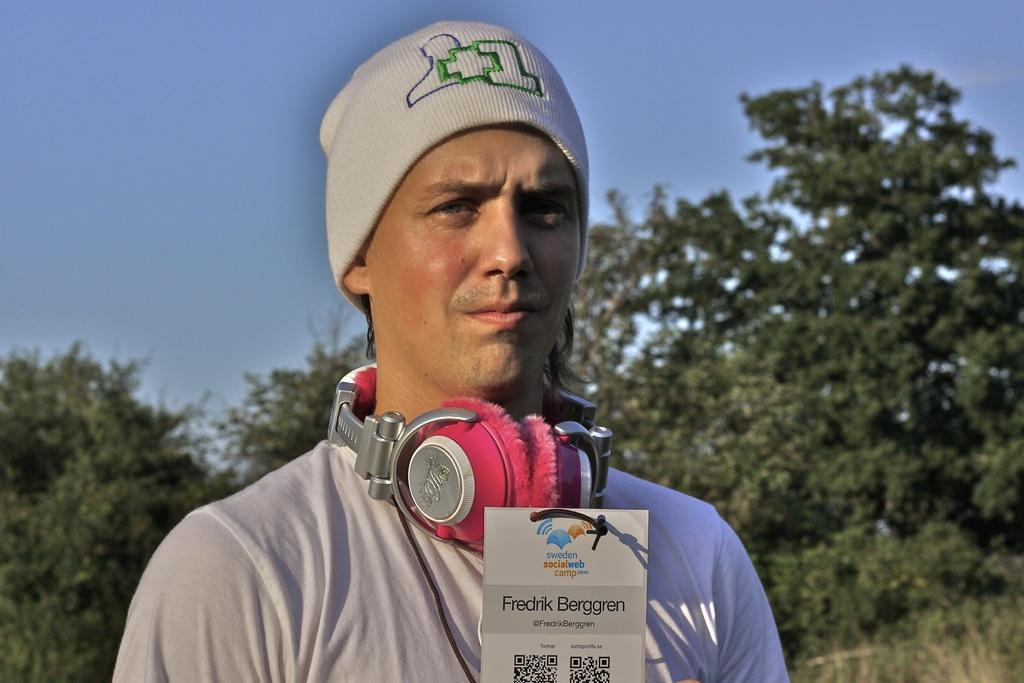What is the man in the image wearing on his head? The man in the image is wearing a headset. What direction is the man looking in? The man is looking forward. What is in front of the man on the table? There is a card in front of the man. What can be seen on the card? The card has QR codes on it. What can be seen in the background of the image? There are trees and the sky visible in the background of the image. What is the color of the sky in the image? The sky is blue in color. What type of cushion is the man using to support his back in the image? There is no cushion visible in the image, and the man is not shown sitting or leaning against anything. 